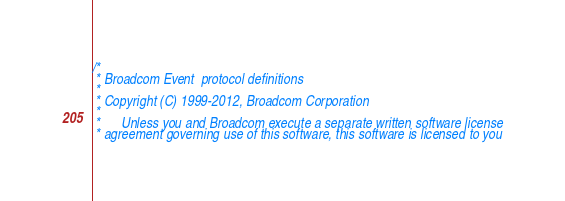<code> <loc_0><loc_0><loc_500><loc_500><_C_>/*
 * Broadcom Event  protocol definitions
 *
 * Copyright (C) 1999-2012, Broadcom Corporation
 *
 *      Unless you and Broadcom execute a separate written software license
 * agreement governing use of this software, this software is licensed to you</code> 